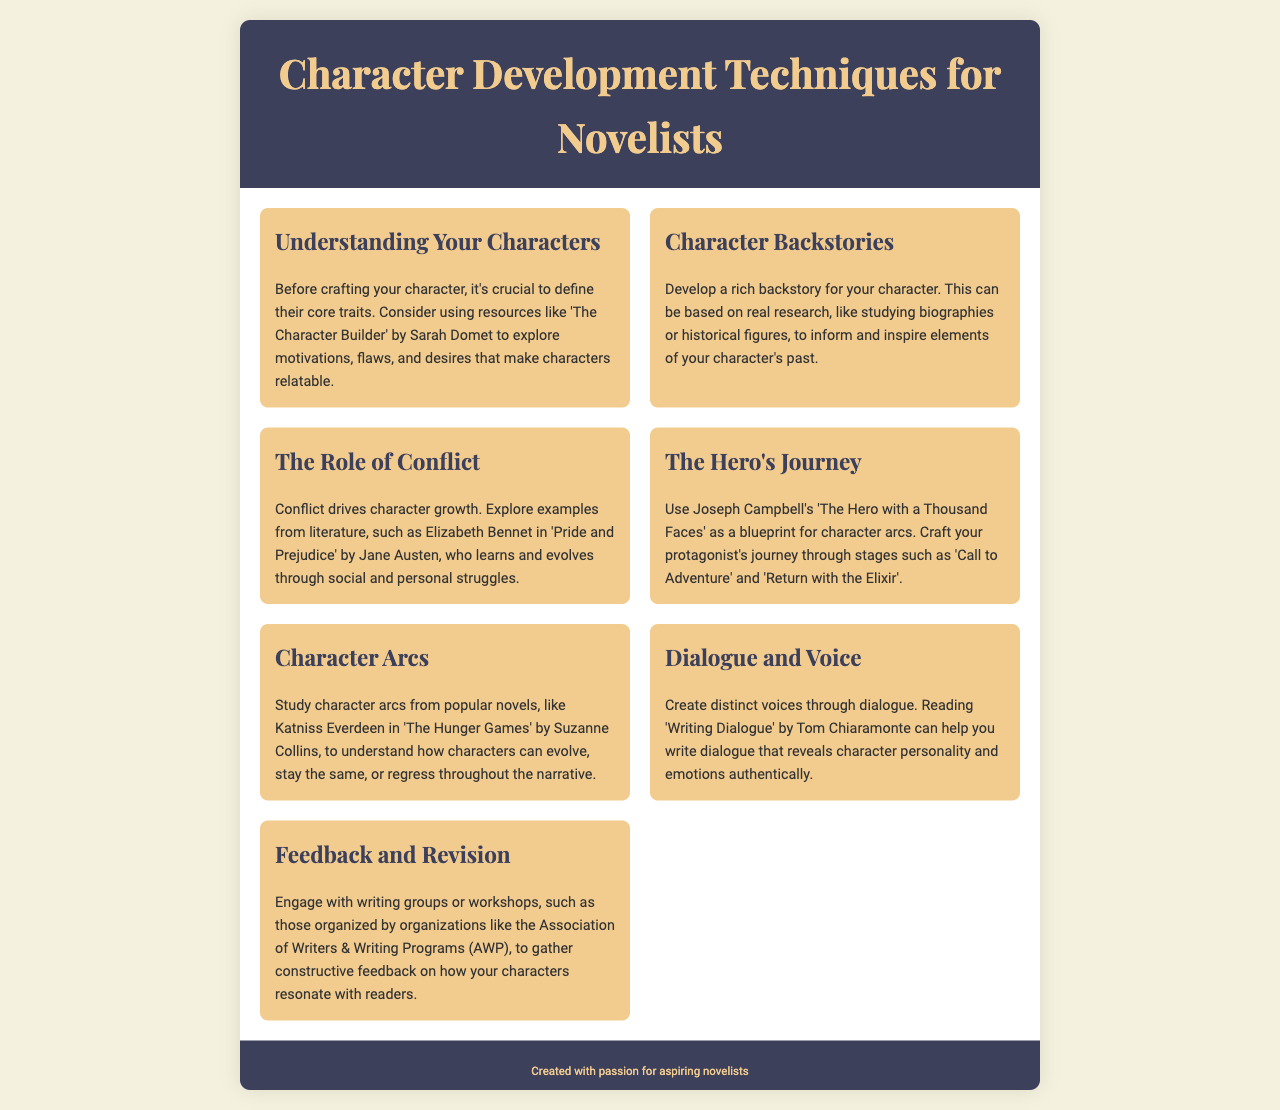What is the title of the brochure? The title is stated prominently in the header section of the document.
Answer: Character Development Techniques for Novelists Who authored 'The Hero with a Thousand Faces'? This information is typically included in references to the book in the content sections.
Answer: Joseph Campbell Which character is mentioned as an example in relation to conflict? The section discusses character growth through conflict, mentioning a specific character from literature.
Answer: Elizabeth Bennet What resource is suggested for understanding dialogue? The document provides resources for developing specific writing skills, including this aspect.
Answer: Writing Dialogue How many sections are there in the content? The number of sections can be counted from the grid layout provided in the content area of the document.
Answer: Seven What character's arc is studied in the document? The document references a specific character to illustrate the concept of character arcs.
Answer: Katniss Everdeen Which organization is mentioned for gathering feedback? The brochure includes details about an organization that helps writers connect for feedback.
Answer: Association of Writers & Writing Programs 